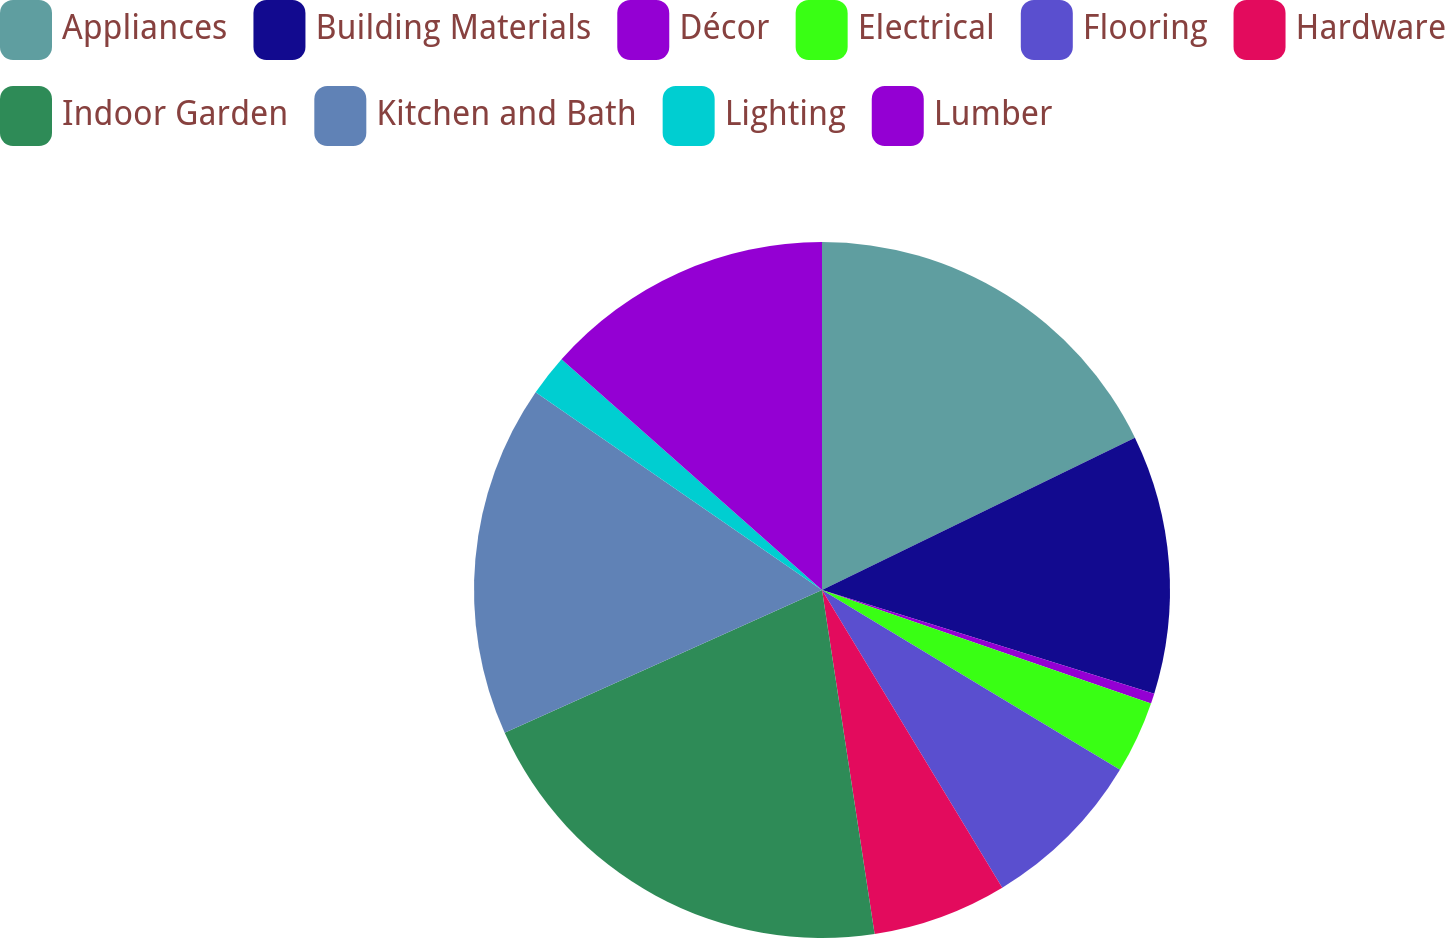<chart> <loc_0><loc_0><loc_500><loc_500><pie_chart><fcel>Appliances<fcel>Building Materials<fcel>Décor<fcel>Electrical<fcel>Flooring<fcel>Hardware<fcel>Indoor Garden<fcel>Kitchen and Bath<fcel>Lighting<fcel>Lumber<nl><fcel>17.79%<fcel>12.02%<fcel>0.47%<fcel>3.36%<fcel>7.69%<fcel>6.25%<fcel>20.68%<fcel>16.35%<fcel>1.92%<fcel>13.46%<nl></chart> 